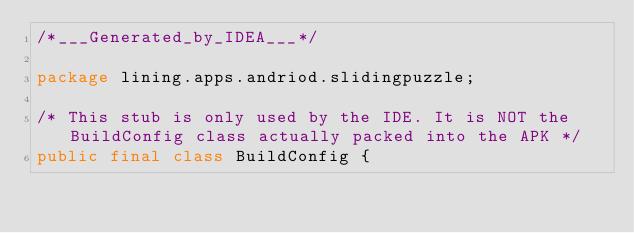Convert code to text. <code><loc_0><loc_0><loc_500><loc_500><_Java_>/*___Generated_by_IDEA___*/

package lining.apps.andriod.slidingpuzzle;

/* This stub is only used by the IDE. It is NOT the BuildConfig class actually packed into the APK */
public final class BuildConfig {</code> 